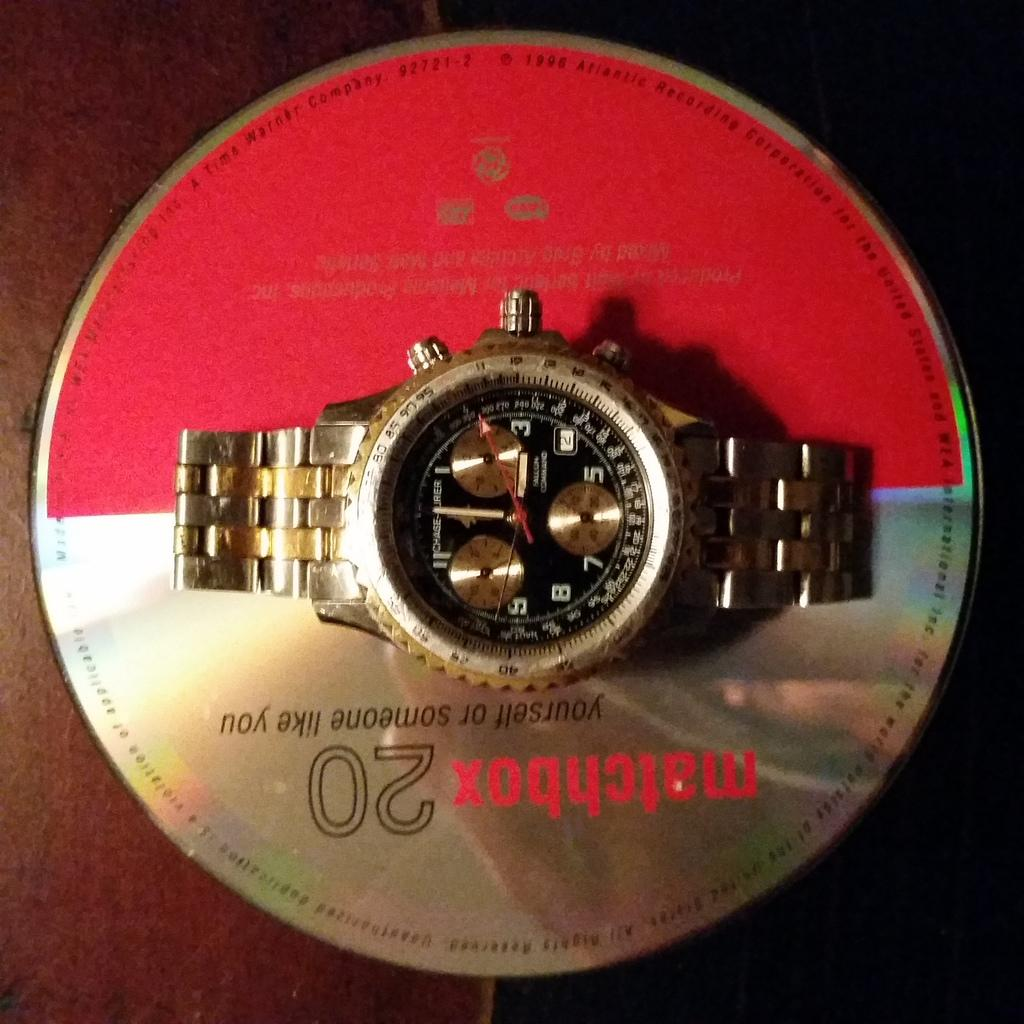<image>
Summarize the visual content of the image. Compact disc that is upside down with a watch on top of it 